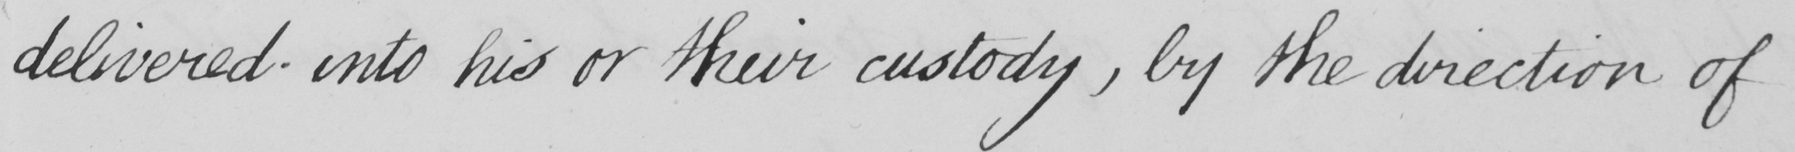Please provide the text content of this handwritten line. delivered into his or their custody  , by the direction of 